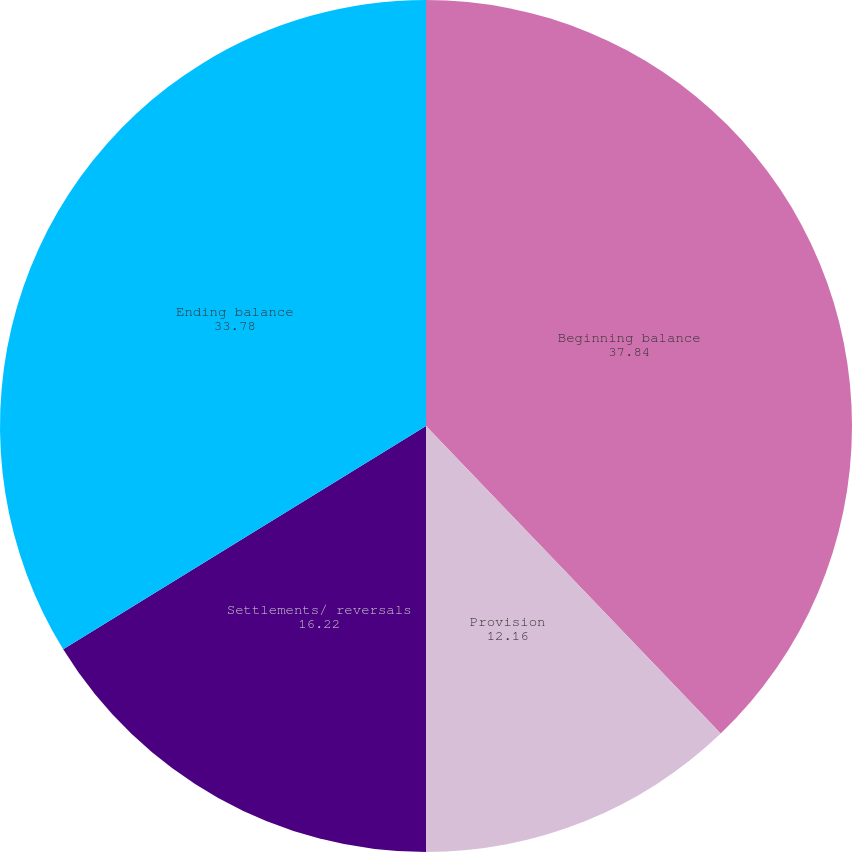<chart> <loc_0><loc_0><loc_500><loc_500><pie_chart><fcel>Beginning balance<fcel>Provision<fcel>Settlements/ reversals<fcel>Ending balance<nl><fcel>37.84%<fcel>12.16%<fcel>16.22%<fcel>33.78%<nl></chart> 